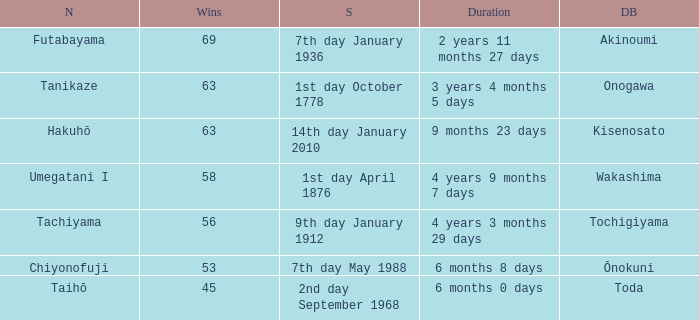Give me the full table as a dictionary. {'header': ['N', 'Wins', 'S', 'Duration', 'DB'], 'rows': [['Futabayama', '69', '7th day January 1936', '2 years 11 months 27 days', 'Akinoumi'], ['Tanikaze', '63', '1st day October 1778', '3 years 4 months 5 days', 'Onogawa'], ['Hakuhō', '63', '14th day January 2010', '9 months 23 days', 'Kisenosato'], ['Umegatani I', '58', '1st day April 1876', '4 years 9 months 7 days', 'Wakashima'], ['Tachiyama', '56', '9th day January 1912', '4 years 3 months 29 days', 'Tochigiyama'], ['Chiyonofuji', '53', '7th day May 1988', '6 months 8 days', 'Ōnokuni'], ['Taihō', '45', '2nd day September 1968', '6 months 0 days', 'Toda']]} What is the Duration for less than 53 consecutive wins? 6 months 0 days. 